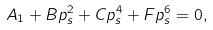<formula> <loc_0><loc_0><loc_500><loc_500>A _ { 1 } + B p _ { s } ^ { 2 } + C p _ { s } ^ { 4 } + F p _ { s } ^ { 6 } = 0 ,</formula> 